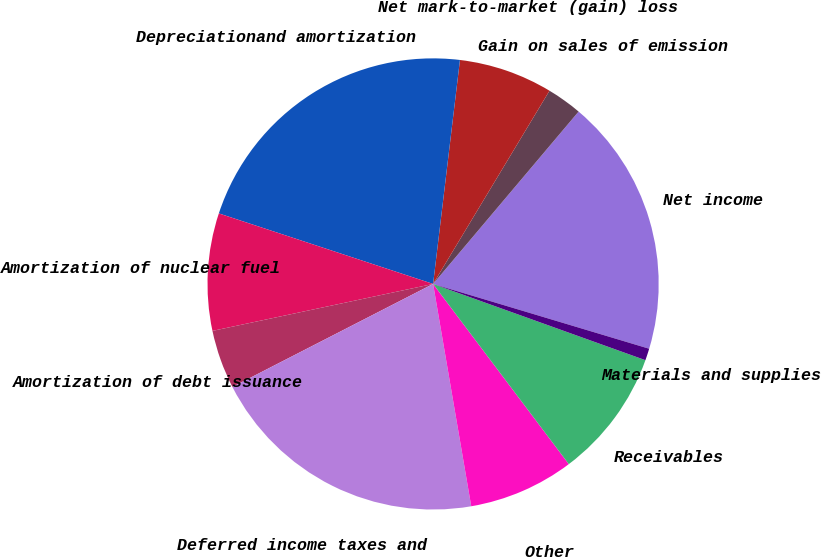<chart> <loc_0><loc_0><loc_500><loc_500><pie_chart><fcel>Net income<fcel>Gain on sales of emission<fcel>Net mark-to-market (gain) loss<fcel>Depreciationand amortization<fcel>Amortization of nuclear fuel<fcel>Amortization of debt issuance<fcel>Deferred income taxes and<fcel>Other<fcel>Receivables<fcel>Materials and supplies<nl><fcel>18.48%<fcel>2.53%<fcel>6.73%<fcel>21.84%<fcel>8.4%<fcel>4.21%<fcel>20.16%<fcel>7.57%<fcel>9.24%<fcel>0.85%<nl></chart> 